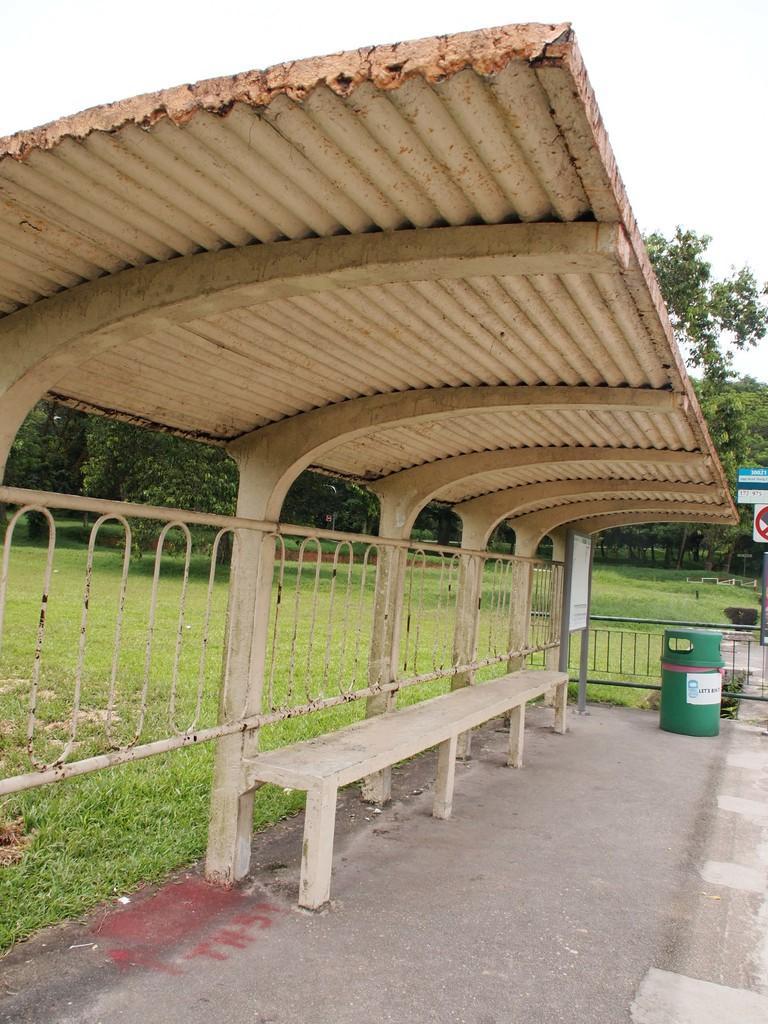Describe this image in one or two sentences. In this image there is a shelter under the shelter there is a bench, beside that there is dustbin, in the background there is garden trees and the sky. 